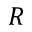<formula> <loc_0><loc_0><loc_500><loc_500>R</formula> 